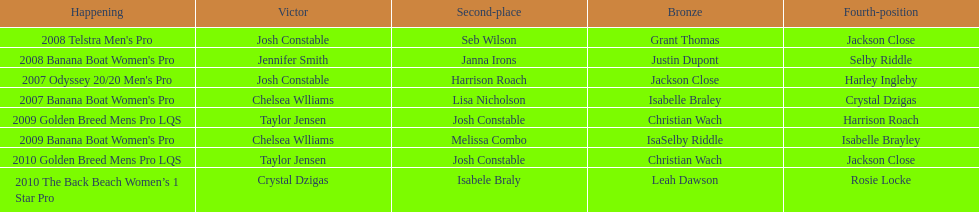How many times was josh constable the winner after 2007? 1. 